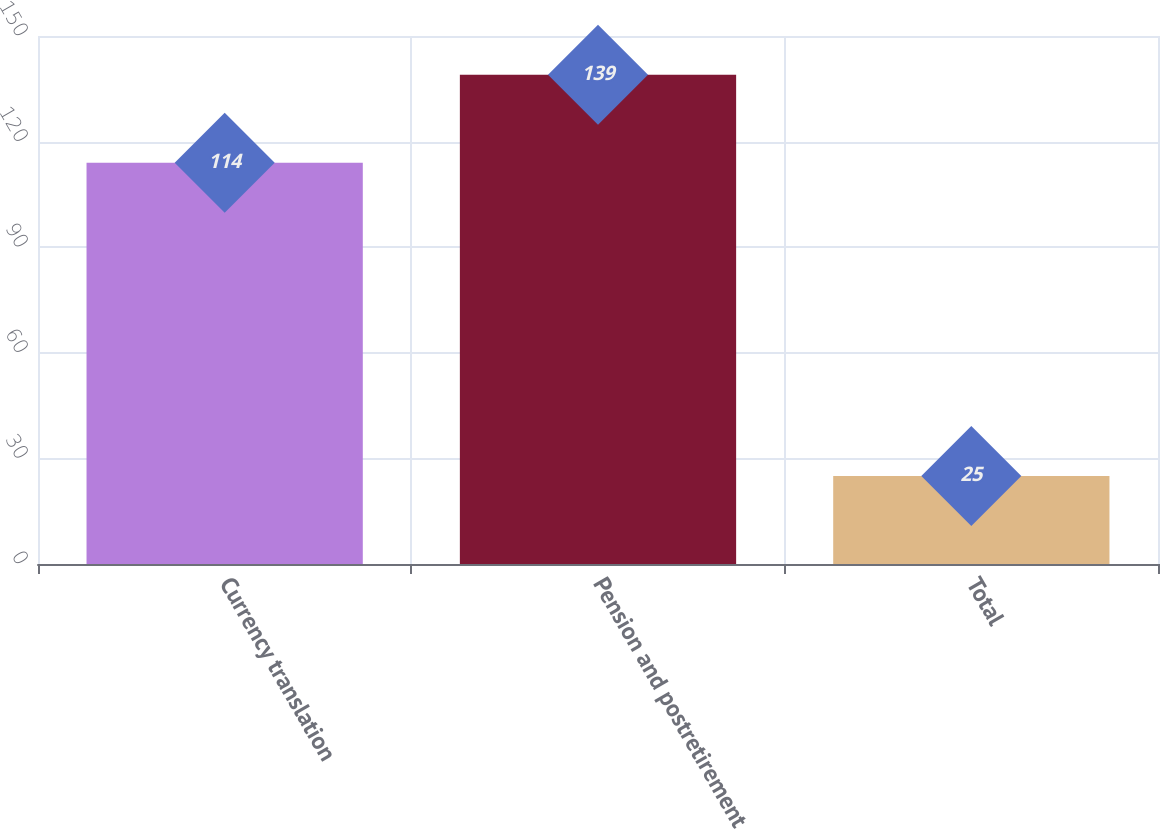Convert chart to OTSL. <chart><loc_0><loc_0><loc_500><loc_500><bar_chart><fcel>Currency translation<fcel>Pension and postretirement<fcel>Total<nl><fcel>114<fcel>139<fcel>25<nl></chart> 